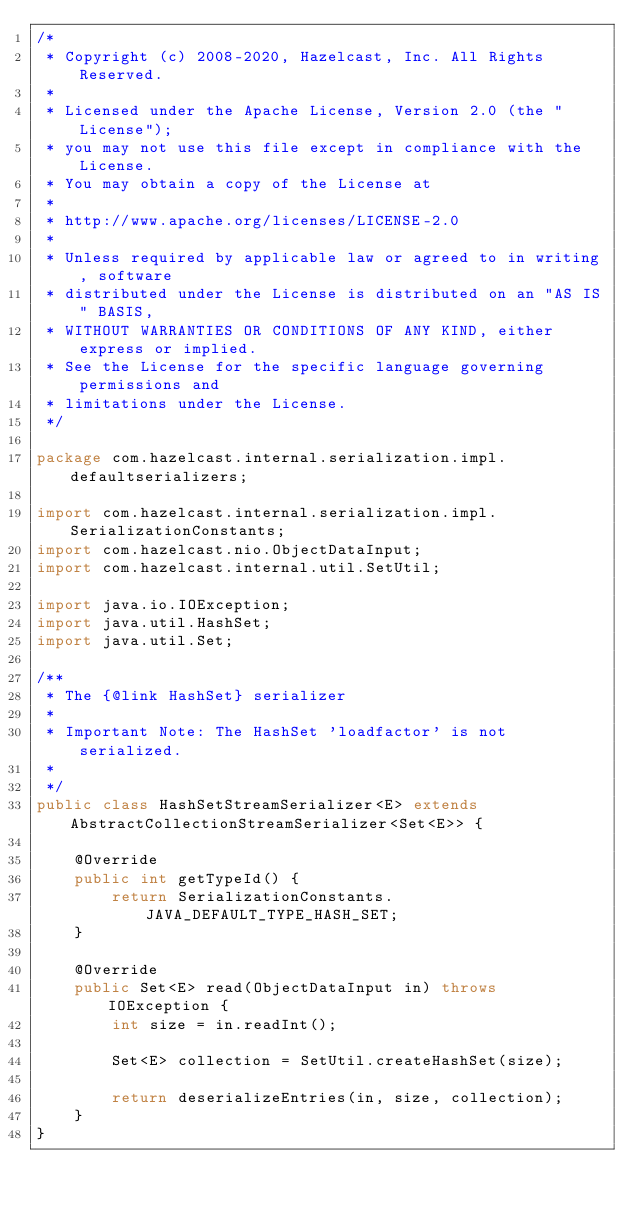<code> <loc_0><loc_0><loc_500><loc_500><_Java_>/*
 * Copyright (c) 2008-2020, Hazelcast, Inc. All Rights Reserved.
 *
 * Licensed under the Apache License, Version 2.0 (the "License");
 * you may not use this file except in compliance with the License.
 * You may obtain a copy of the License at
 *
 * http://www.apache.org/licenses/LICENSE-2.0
 *
 * Unless required by applicable law or agreed to in writing, software
 * distributed under the License is distributed on an "AS IS" BASIS,
 * WITHOUT WARRANTIES OR CONDITIONS OF ANY KIND, either express or implied.
 * See the License for the specific language governing permissions and
 * limitations under the License.
 */

package com.hazelcast.internal.serialization.impl.defaultserializers;

import com.hazelcast.internal.serialization.impl.SerializationConstants;
import com.hazelcast.nio.ObjectDataInput;
import com.hazelcast.internal.util.SetUtil;

import java.io.IOException;
import java.util.HashSet;
import java.util.Set;

/**
 * The {@link HashSet} serializer
 *
 * Important Note: The HashSet 'loadfactor' is not serialized.
 *
 */
public class HashSetStreamSerializer<E> extends AbstractCollectionStreamSerializer<Set<E>> {

    @Override
    public int getTypeId() {
        return SerializationConstants.JAVA_DEFAULT_TYPE_HASH_SET;
    }

    @Override
    public Set<E> read(ObjectDataInput in) throws IOException {
        int size = in.readInt();

        Set<E> collection = SetUtil.createHashSet(size);

        return deserializeEntries(in, size, collection);
    }
}
</code> 